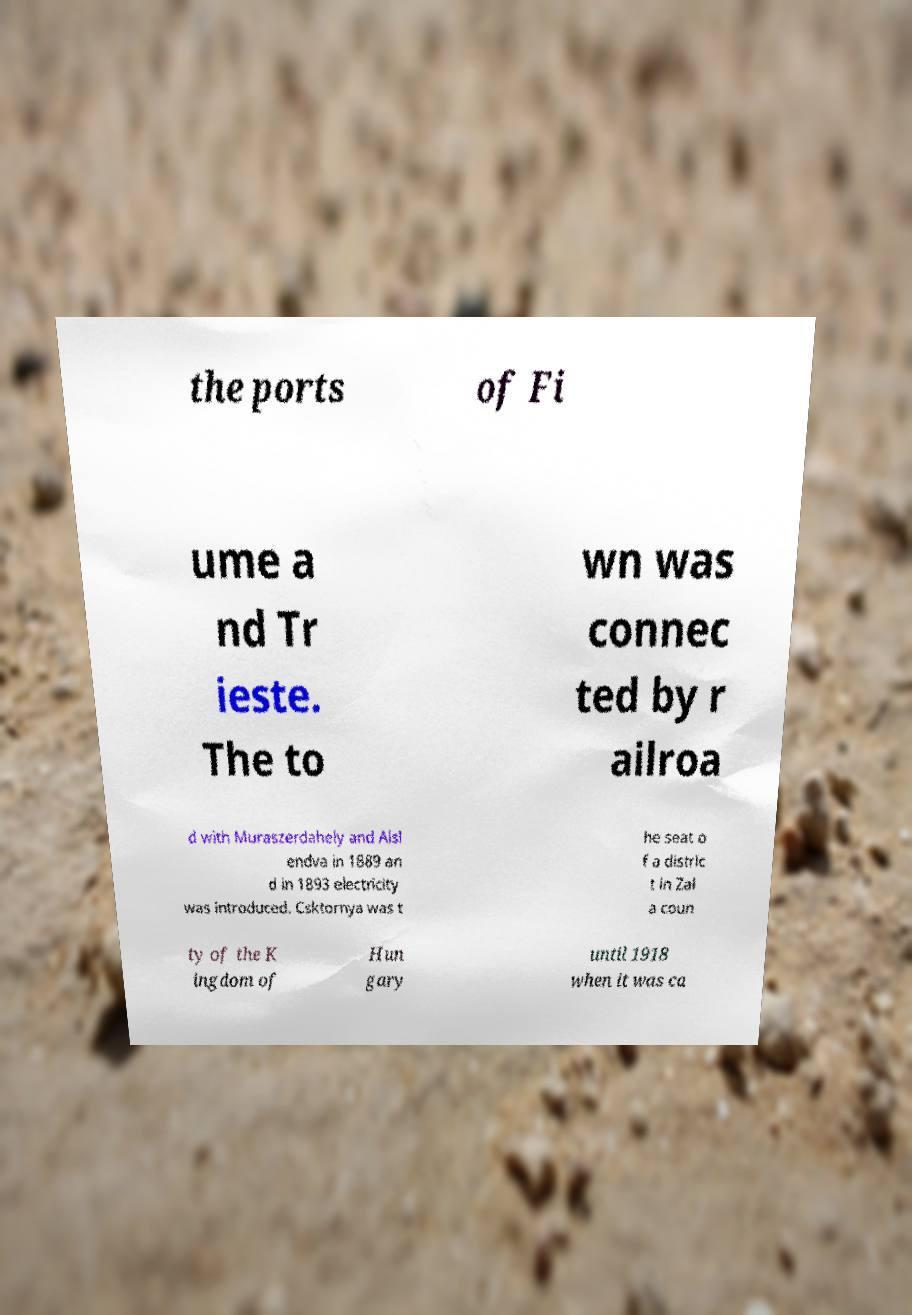Please read and relay the text visible in this image. What does it say? the ports of Fi ume a nd Tr ieste. The to wn was connec ted by r ailroa d with Muraszerdahely and Alsl endva in 1889 an d in 1893 electricity was introduced. Csktornya was t he seat o f a distric t in Zal a coun ty of the K ingdom of Hun gary until 1918 when it was ca 